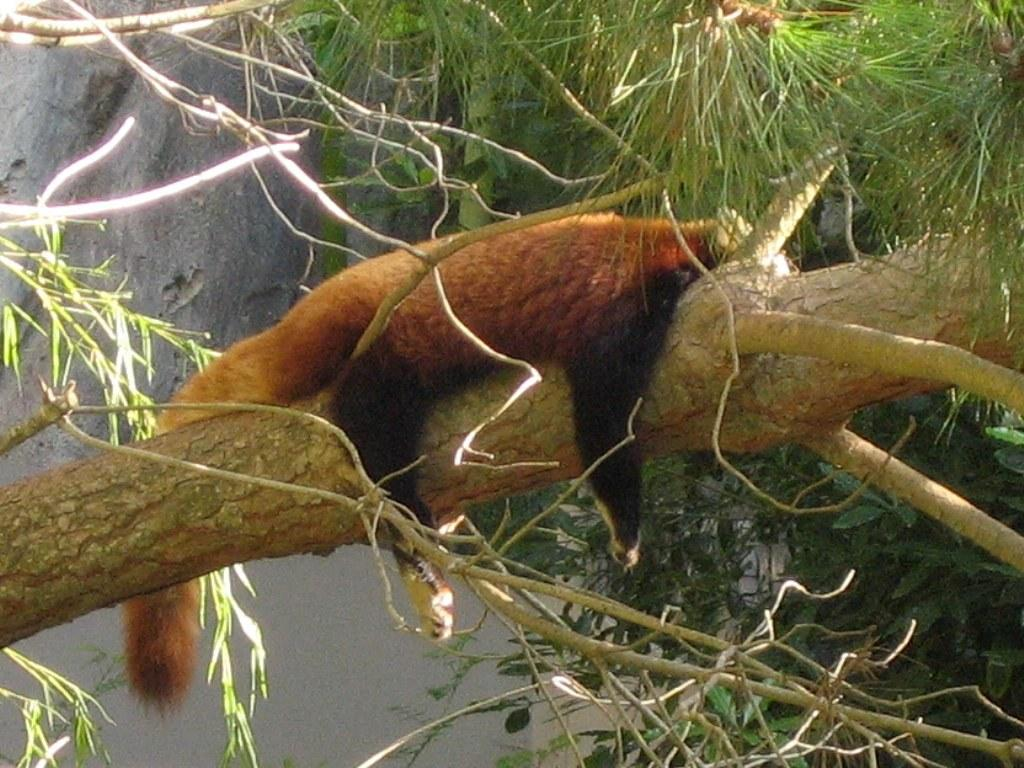What type of animal is in the image? There is a red panda in the image. What is the red panda doing in the image? The red panda is lying on a tree branch. What else can be seen in the image besides the red panda? There are other stems and branches of trees visible in the image. What is on the right hand side of the image? There is a wall on the right hand side of the image. What type of underwear is the red panda wearing in the image? Red pandas do not wear underwear, and there is no underwear visible in the image. 